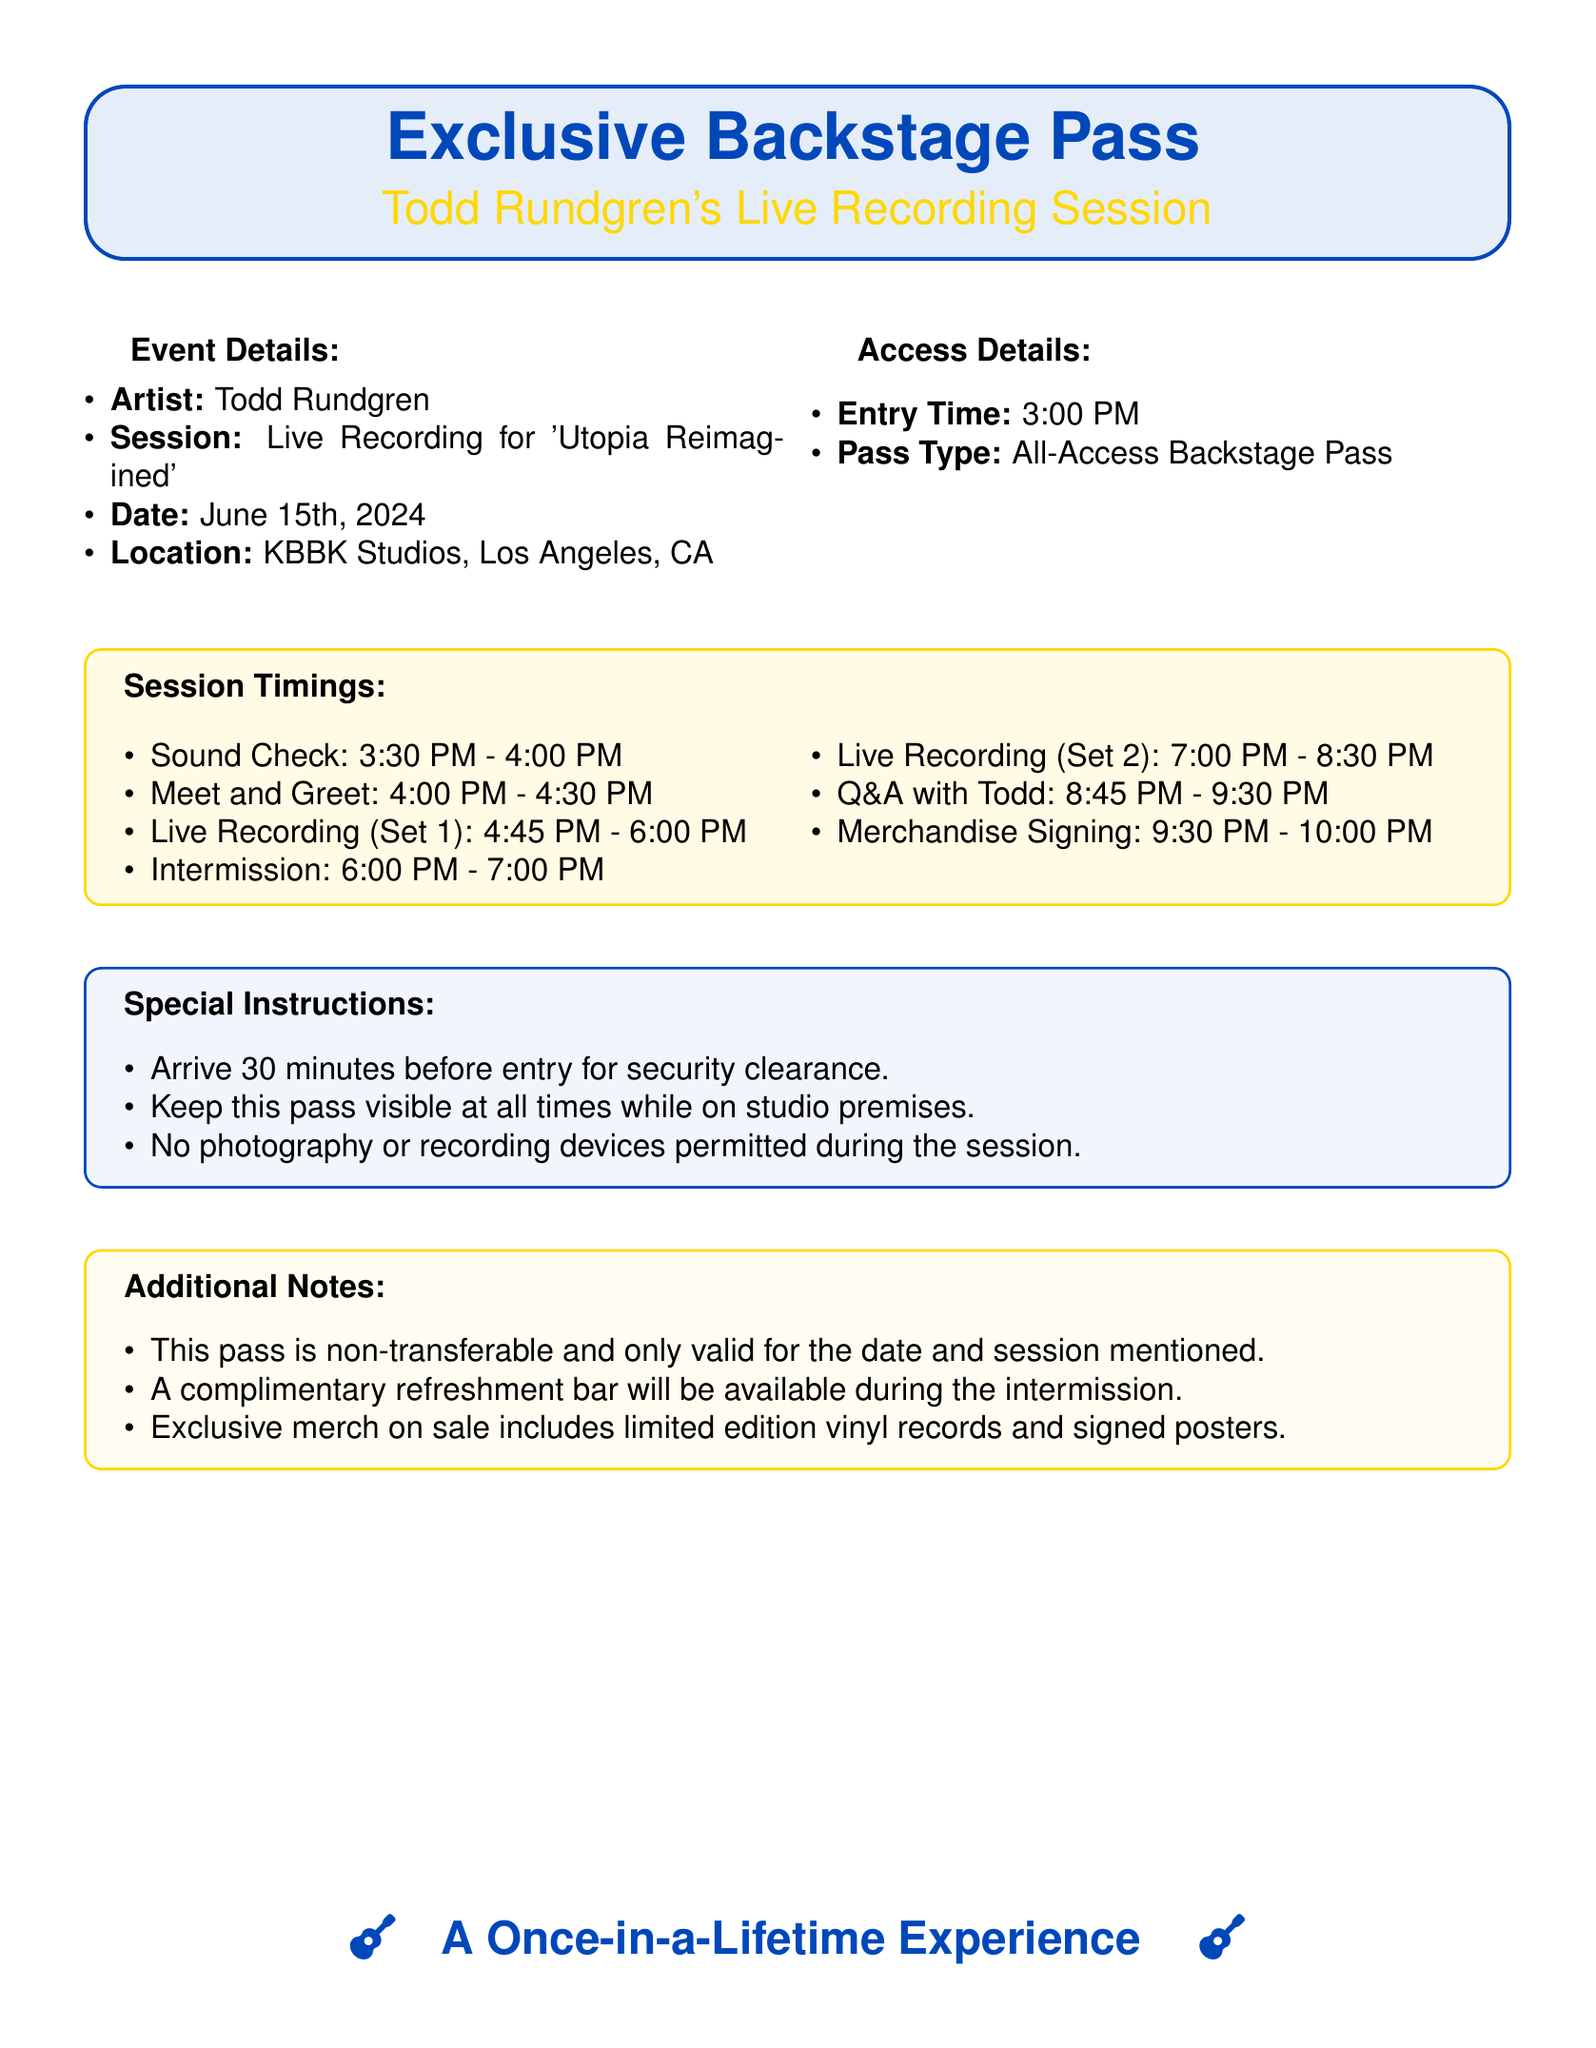what is the date of the live recording session? The date is explicitly mentioned in the document as June 15th, 2024.
Answer: June 15th, 2024 where is the live recording session taking place? The location is specified in the document as KBBK Studios, Los Angeles, CA.
Answer: KBBK Studios, Los Angeles, CA what time does the entry to the event start? The entry time is detailed in the access details section of the document as 3:00 PM.
Answer: 3:00 PM how long does the sound check last? The duration of the sound check is from 3:30 PM to 4:00 PM, which is 30 minutes.
Answer: 30 minutes what follows the live recording set 1? The schedule indicates there is an intermission following the first set at 6:00 PM.
Answer: Intermission is photography allowed during the session? The special instructions specify that no photography or recording devices are permitted during the session.
Answer: No what is provided during the intermission? The additional notes mention a complimentary refreshment bar will be available.
Answer: Refreshment bar what type of pass is offered for this event? The document states that the type of pass provided is an All-Access Backstage Pass.
Answer: All-Access Backstage Pass how long is the Q&A session with Todd? The timing for the Q&A session is from 8:45 PM to 9:30 PM, which is 45 minutes long.
Answer: 45 minutes 